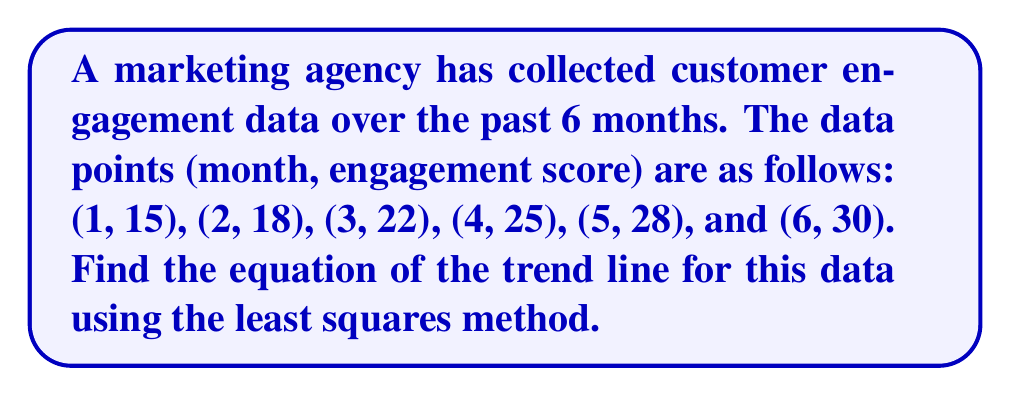Teach me how to tackle this problem. To find the equation of the trend line using the least squares method, we need to follow these steps:

1) Let's define our variables:
   $x$ = month number
   $y$ = engagement score
   $n$ = number of data points (6 in this case)

2) Calculate the sums we need:
   $\sum x = 1 + 2 + 3 + 4 + 5 + 6 = 21$
   $\sum y = 15 + 18 + 22 + 25 + 28 + 30 = 138$
   $\sum xy = (1)(15) + (2)(18) + (3)(22) + (4)(25) + (5)(28) + (6)(30) = 580$
   $\sum x^2 = 1^2 + 2^2 + 3^2 + 4^2 + 5^2 + 6^2 = 91$

3) Use the least squares formulas to calculate the slope (m) and y-intercept (b):

   $m = \frac{n\sum xy - \sum x \sum y}{n\sum x^2 - (\sum x)^2}$
   
   $m = \frac{6(580) - (21)(138)}{6(91) - (21)^2} = \frac{3480 - 2898}{546 - 441} = \frac{582}{105} = 5.54$

   $b = \frac{\sum y - m\sum x}{n}$
   
   $b = \frac{138 - 5.54(21)}{6} = \frac{138 - 116.34}{6} = 3.61$

4) The equation of the trend line is in the form $y = mx + b$

Therefore, the equation of the trend line is:

$y = 5.54x + 3.61$

This equation represents the best-fit line for the customer engagement data, allowing the marketing agency to predict future engagement scores and analyze trends while complying with data privacy laws.
Answer: $y = 5.54x + 3.61$ 